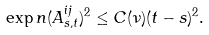Convert formula to latex. <formula><loc_0><loc_0><loc_500><loc_500>\exp n { ( A _ { s , t } ^ { i j } ) ^ { 2 } } \leq C ( \nu ) ( t - s ) ^ { 2 } .</formula> 